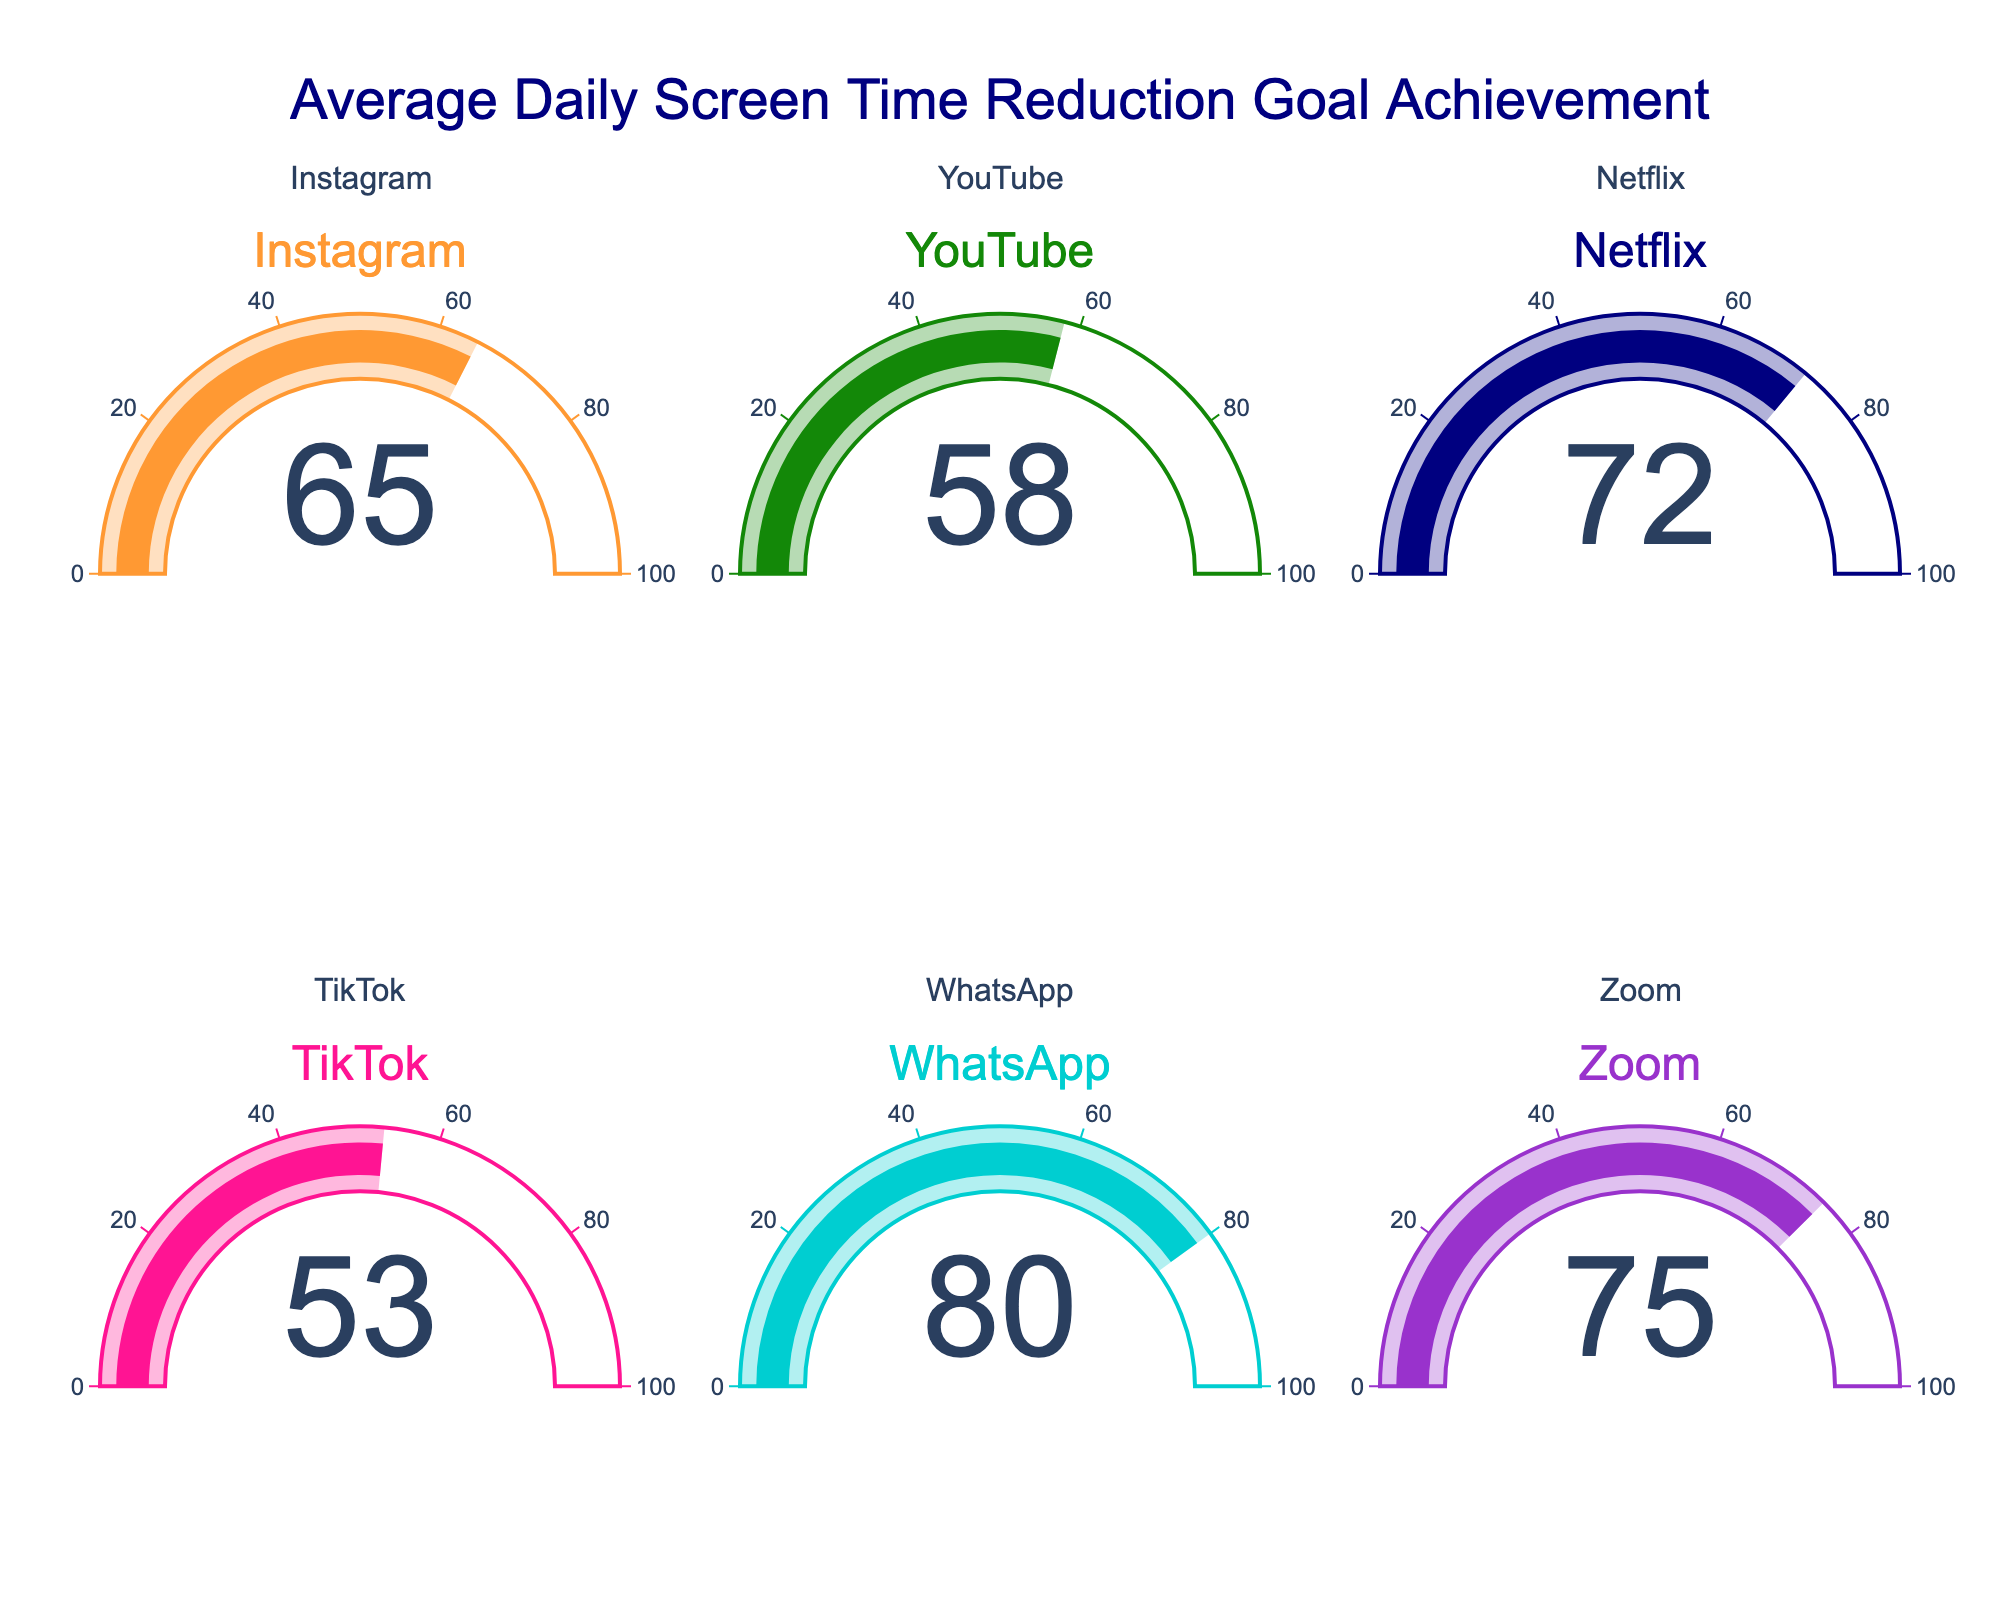What is the percentage goal achievement for Instagram? The gauge chart corresponding to Instagram displays a value indicating the goal achievement percentage.
Answer: 65 Which app has the highest percentage of daily screen time reduction goal achievement? By comparing the goal achievement percentages shown on each gauge chart, we see that WhatsApp has the highest value.
Answer: WhatsApp What is the average goal achievement percentage across all the apps? Add up the percentages for all the apps: (65 + 58 + 72 + 53 + 80 + 75) = 403. Then, divide by the number of apps, which is 6. So, 403 / 6 ≈ 67.17
Answer: 67.17 Which app has the lowest percentage of daily screen time reduction goal achievement? By comparing the percentages on each gauge chart, TikTok has the lowest value.
Answer: TikTok Are there more apps with goal achievement percentages above 70% or below 60%? There are three apps above 70% (Netflix, WhatsApp, and Zoom) and two apps below 60% (YouTube and TikTok).
Answer: Above 70% What is the difference in goal achievement percentage between Netflix and Zoom? The percentage for Netflix is 72, and for Zoom, it is 75. The difference is 75 - 72 = 3.
Answer: 3 How many apps have at least 60% goal achievement? Apps with at least 60% are Instagram, Netflix, WhatsApp, and Zoom. There are four such apps.
Answer: 4 What is the median percentage of daily screen time reduction goal achievement? Arrange the percentages in ascending order: 53, 58, 65, 72, 75, 80. The median is the average of the two middle values, (65 + 72) / 2 = 68.5.
Answer: 68.5 Which apps have goal achievement percentages between 60% and 70%? The apps with percentages between 60% and 70% are Instagram and Netflix.
Answer: Instagram, Netflix What is the percentage difference between the highest and the lowest daily screen time reduction goal achievement? The highest percentage is 80 (WhatsApp) and the lowest is 53 (TikTok). The difference is 80 - 53 = 27.
Answer: 27 